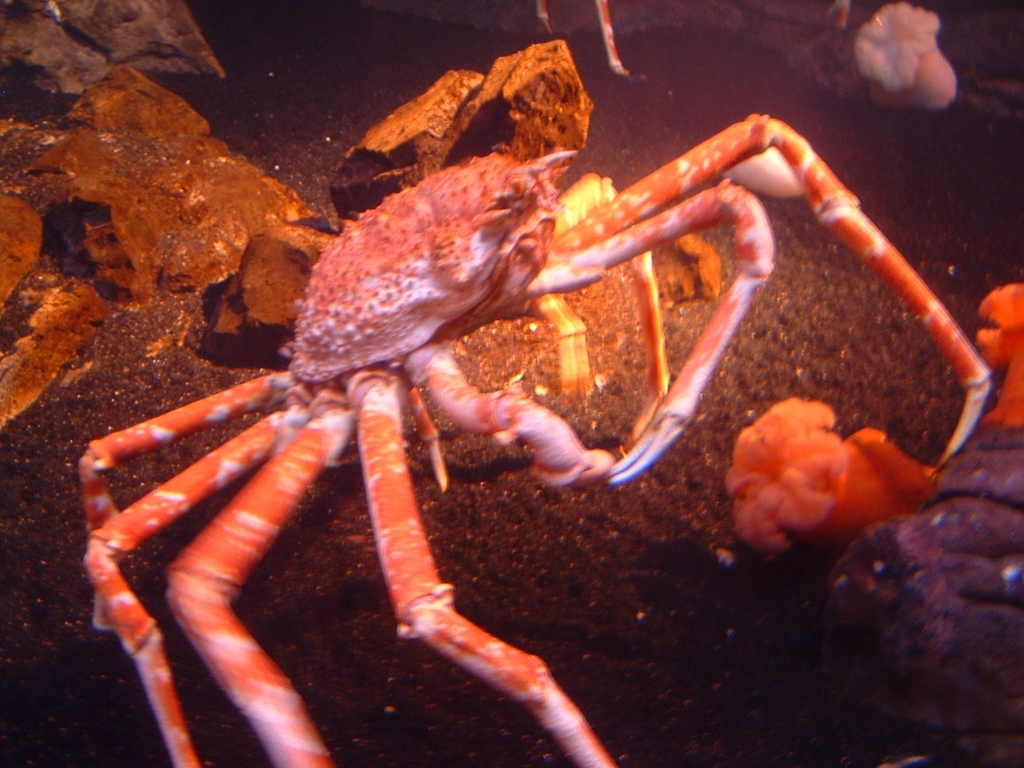What species of crab is this and what can you tell me about its habitat? This appears to be a spider crab, known for their long slender legs and relatively small body. They are often found on rocky and muddy ocean bottoms where they can blend in because their exoskeletons often accumulate sediments and other sea-life, providing them with effective camouflage. They are fascinating creatures that play a role in the marine ecosystem as both predator and prey. 